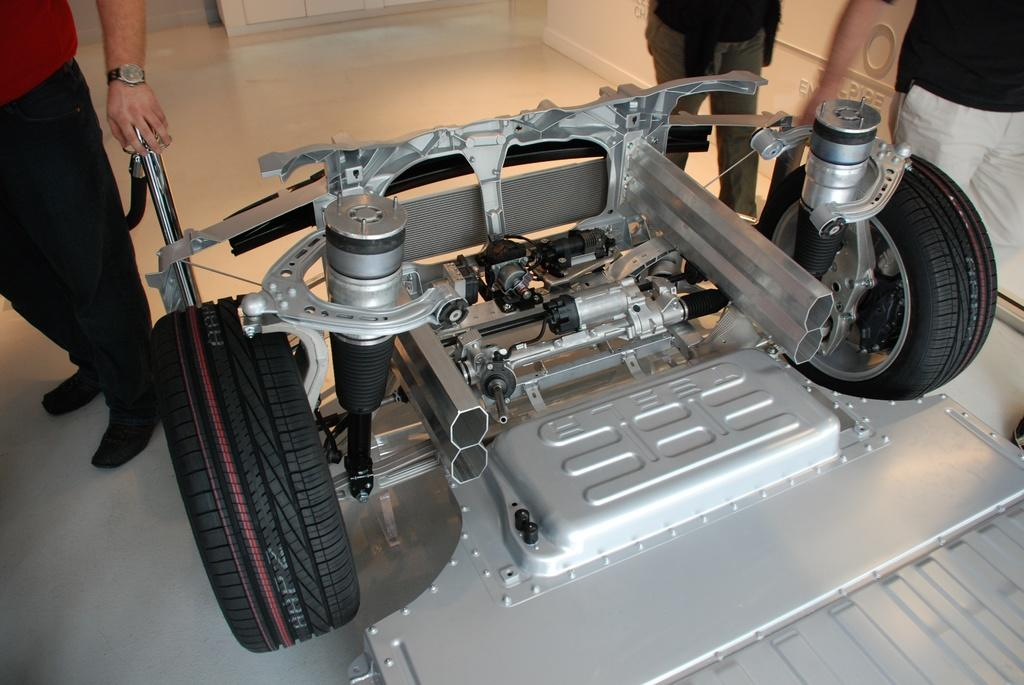What type of object is partially visible in the image? There are parts of a car visible in the image. How many people can be seen in the image? There are three people standing on the floor in the image. What type of recess can be seen in the middle of the car? There is no recess visible in the image, as it only shows parts of a car and three people standing on the floor. 